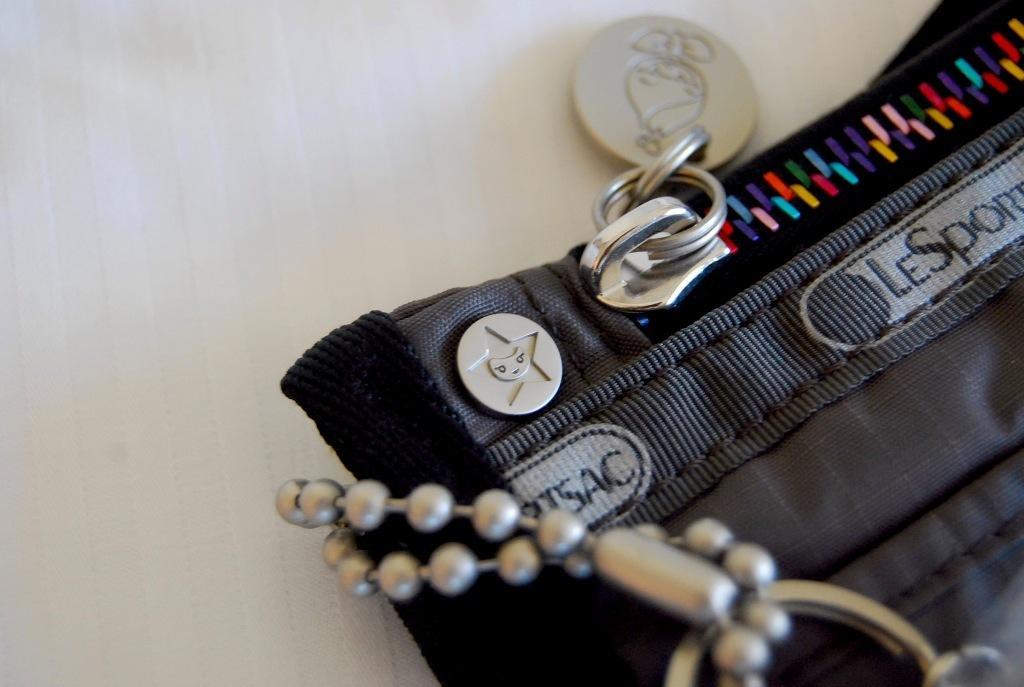How would you summarize this image in a sentence or two? In this image I can see the black color pouch and the zip. It is on the white color surface. 